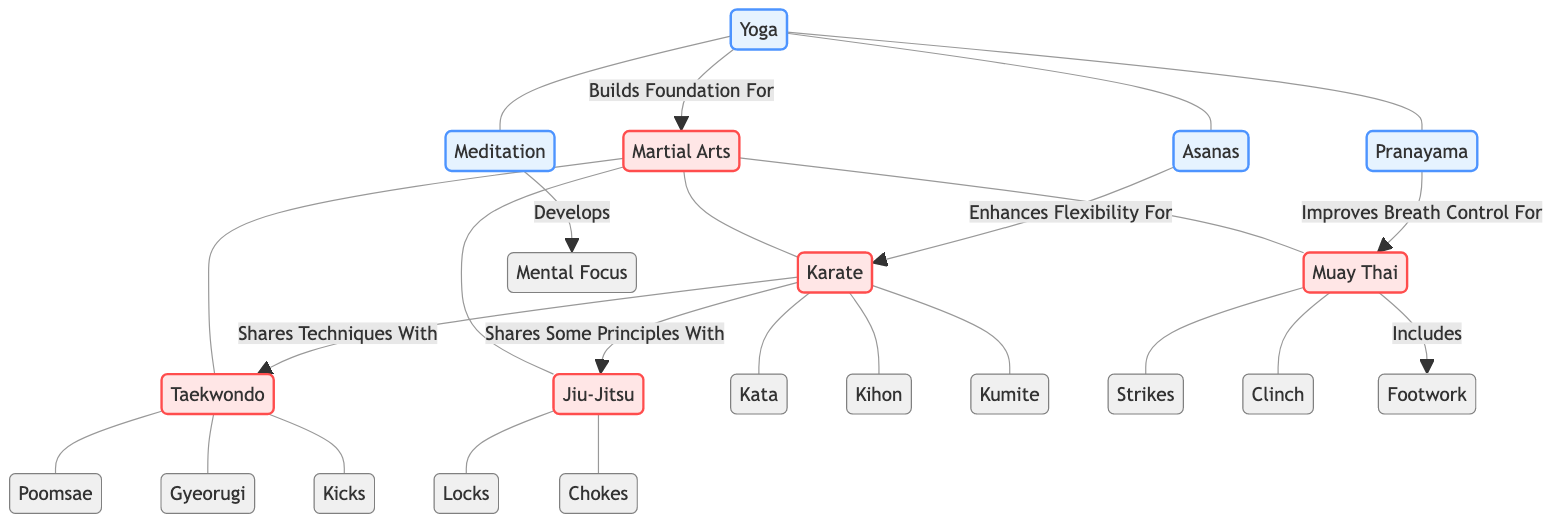What is the core technique associated with Karate? The diagram shows Karate having three associated techniques: Kata, Kihon, and Kumite. Since the question asks for the core technique, any of these can be selected.
Answer: Kata How many forms of Martial Arts are represented in the diagram? There are four forms of Martial Arts listed: Karate, Taekwondo, Jiu-Jitsu, and Muay Thai. Thus, the total count is four.
Answer: 4 What does Yoga build a foundation for? The diagram links Yoga to Martial Arts, indicating that Yoga builds a foundation for various martial arts practices.
Answer: Martial Arts Which technique under Muay Thai is mentioned in the diagram? The diagram indicates three techniques associated with Muay Thai: Strikes, Clinch, and Footwork. Any of these can be considered a correct answer.
Answer: Footwork Which Martial Arts shares techniques with Taekwondo? The diagram specifies that Karate shares techniques with Taekwondo, making it the connecting martial art.
Answer: Karate What specific aspect does Pranayama improve for Muay Thai? According to the diagram, Pranayama is linked to improving breath control for Muay Thai practice.
Answer: Breath Control How many techniques are associated with Taekwondo? Taekwondo is associated with three techniques shown in the diagram: Poomsae, Gyeorugi, and Kicks. Therefore, the count is three.
Answer: 3 What relationship does Meditation have with Mental Focus? The diagram directly indicates that Meditation develops Mental Focus, establishing a clear link between the two.
Answer: Develops Which Martial Art includes footwork as a technique? The diagram shows that Muay Thai includes Footwork among its techniques, establishing it as the answer.
Answer: Muay Thai 